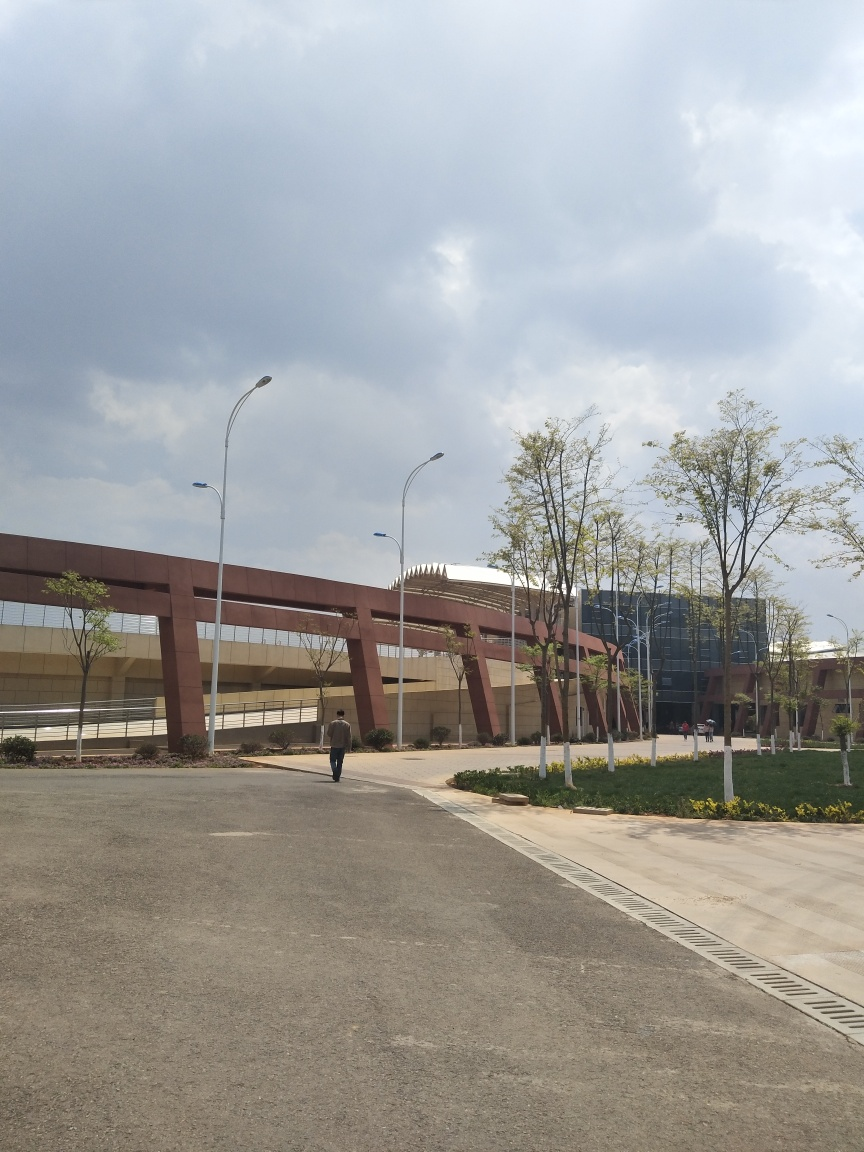What might be the function of the pathway in the centre of the picture? The pathway appears to serve as a walkway or promenade, likely intended for pedestrians to traverse the area. Its wide berth and direct route suggest it's a main thoroughfare within the setting, potentially connecting different areas of a campus or park. 